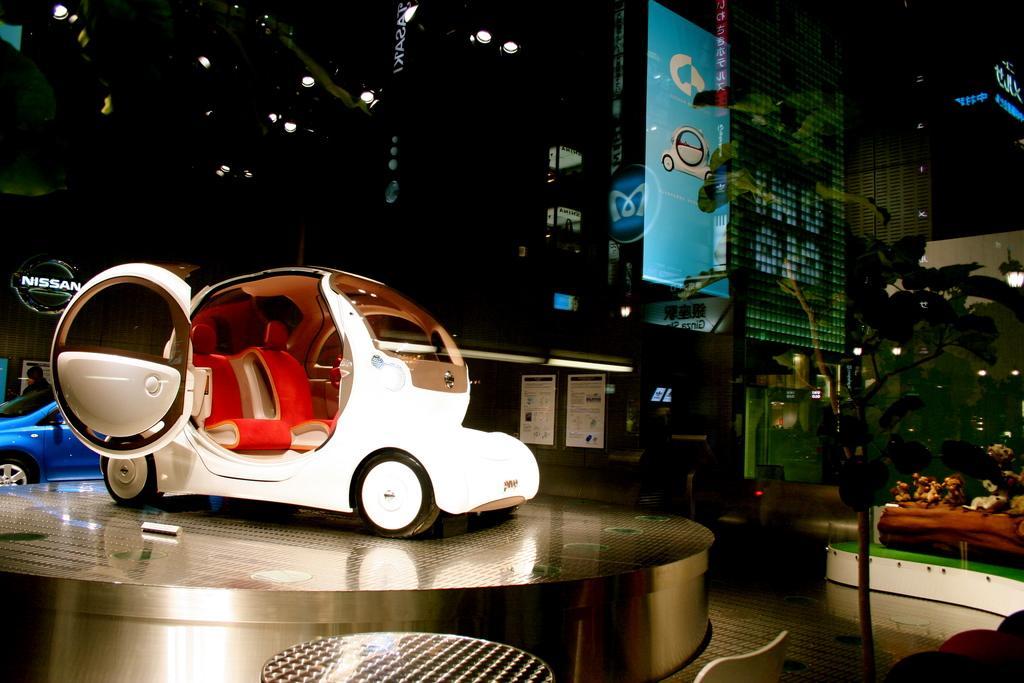Please provide a concise description of this image. In this image I can see a metal stage and on it I can see a vehicle which is black, white and red in color. In the background I can see another vehicle, a person, few buildings, few lights and few other objects. 